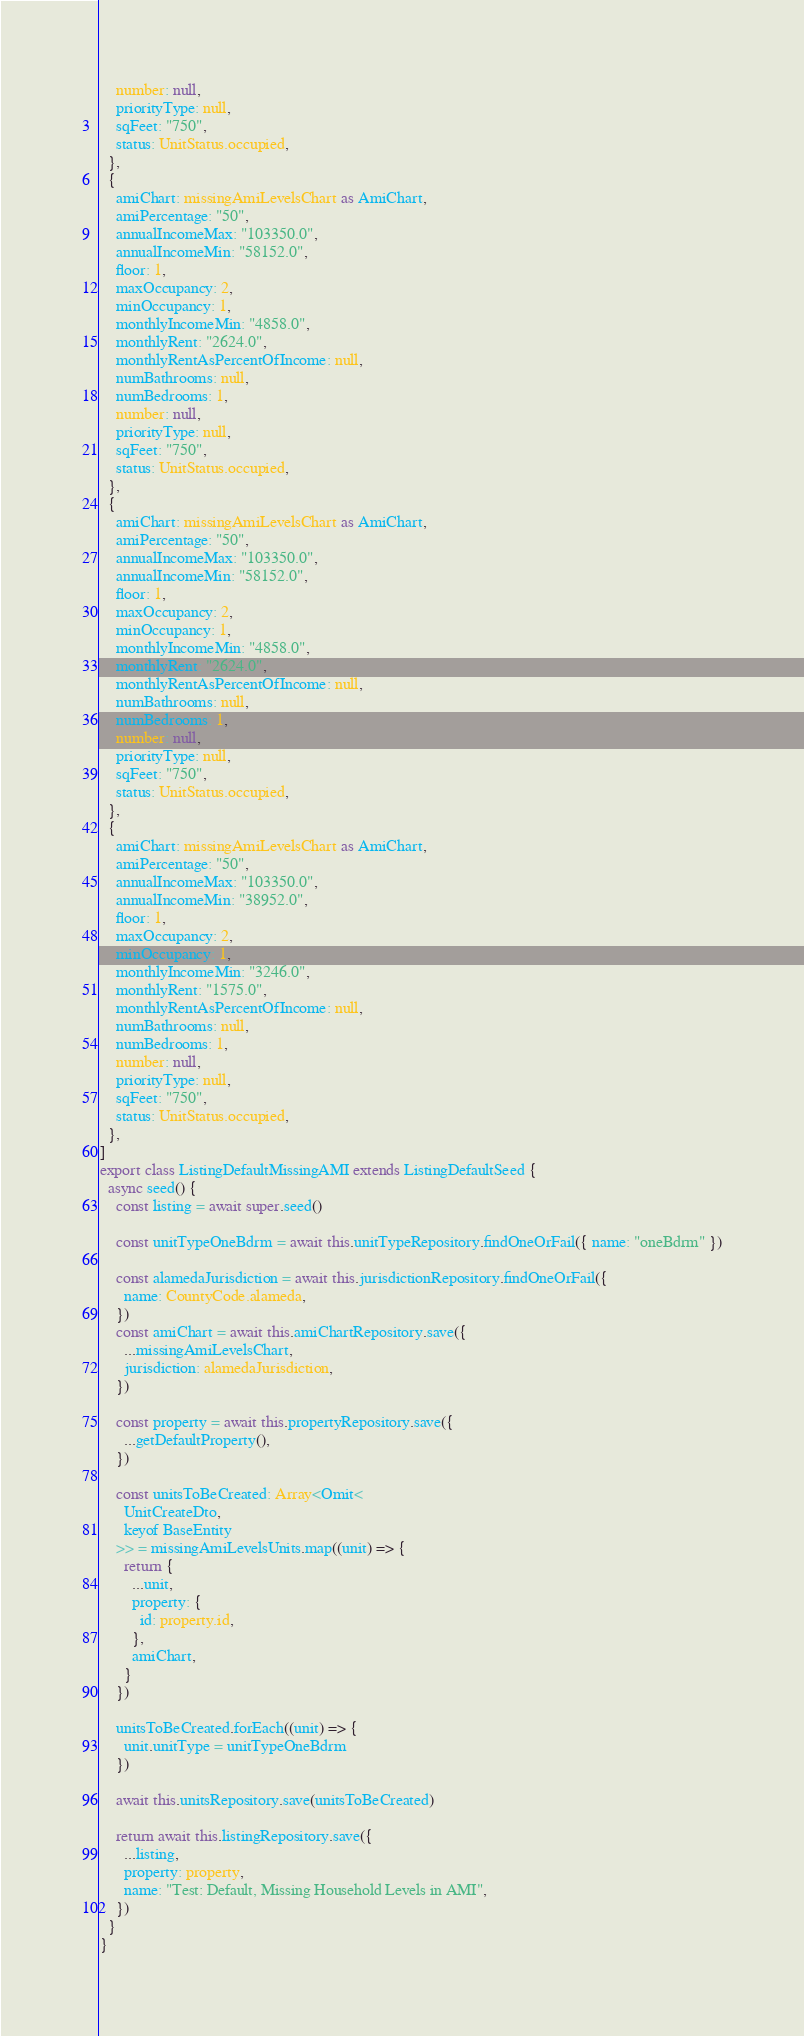Convert code to text. <code><loc_0><loc_0><loc_500><loc_500><_TypeScript_>    number: null,
    priorityType: null,
    sqFeet: "750",
    status: UnitStatus.occupied,
  },
  {
    amiChart: missingAmiLevelsChart as AmiChart,
    amiPercentage: "50",
    annualIncomeMax: "103350.0",
    annualIncomeMin: "58152.0",
    floor: 1,
    maxOccupancy: 2,
    minOccupancy: 1,
    monthlyIncomeMin: "4858.0",
    monthlyRent: "2624.0",
    monthlyRentAsPercentOfIncome: null,
    numBathrooms: null,
    numBedrooms: 1,
    number: null,
    priorityType: null,
    sqFeet: "750",
    status: UnitStatus.occupied,
  },
  {
    amiChart: missingAmiLevelsChart as AmiChart,
    amiPercentage: "50",
    annualIncomeMax: "103350.0",
    annualIncomeMin: "58152.0",
    floor: 1,
    maxOccupancy: 2,
    minOccupancy: 1,
    monthlyIncomeMin: "4858.0",
    monthlyRent: "2624.0",
    monthlyRentAsPercentOfIncome: null,
    numBathrooms: null,
    numBedrooms: 1,
    number: null,
    priorityType: null,
    sqFeet: "750",
    status: UnitStatus.occupied,
  },
  {
    amiChart: missingAmiLevelsChart as AmiChart,
    amiPercentage: "50",
    annualIncomeMax: "103350.0",
    annualIncomeMin: "38952.0",
    floor: 1,
    maxOccupancy: 2,
    minOccupancy: 1,
    monthlyIncomeMin: "3246.0",
    monthlyRent: "1575.0",
    monthlyRentAsPercentOfIncome: null,
    numBathrooms: null,
    numBedrooms: 1,
    number: null,
    priorityType: null,
    sqFeet: "750",
    status: UnitStatus.occupied,
  },
]
export class ListingDefaultMissingAMI extends ListingDefaultSeed {
  async seed() {
    const listing = await super.seed()

    const unitTypeOneBdrm = await this.unitTypeRepository.findOneOrFail({ name: "oneBdrm" })

    const alamedaJurisdiction = await this.jurisdictionRepository.findOneOrFail({
      name: CountyCode.alameda,
    })
    const amiChart = await this.amiChartRepository.save({
      ...missingAmiLevelsChart,
      jurisdiction: alamedaJurisdiction,
    })

    const property = await this.propertyRepository.save({
      ...getDefaultProperty(),
    })

    const unitsToBeCreated: Array<Omit<
      UnitCreateDto,
      keyof BaseEntity
    >> = missingAmiLevelsUnits.map((unit) => {
      return {
        ...unit,
        property: {
          id: property.id,
        },
        amiChart,
      }
    })

    unitsToBeCreated.forEach((unit) => {
      unit.unitType = unitTypeOneBdrm
    })

    await this.unitsRepository.save(unitsToBeCreated)

    return await this.listingRepository.save({
      ...listing,
      property: property,
      name: "Test: Default, Missing Household Levels in AMI",
    })
  }
}
</code> 